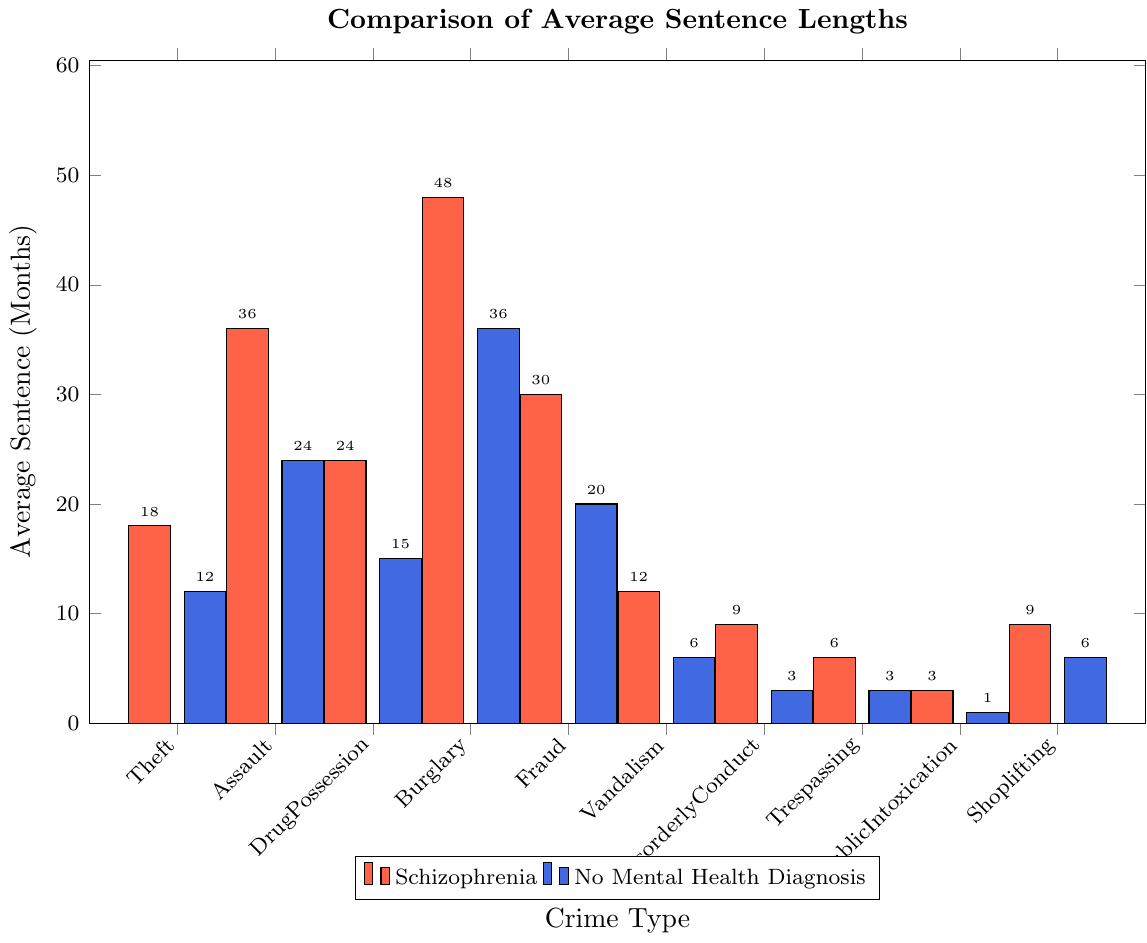Which crime type has the biggest difference in average sentence length between individuals with schizophrenia and those without mental health diagnoses? The difference can be found by subtracting the average sentences of those without mental health diagnoses from those with schizophrenia for each crime, and identifying the largest result. For Burglary, the difference is 48 - 36 = 12 months, this is the largest difference.
Answer: Burglary For which crime type is the average sentence length equal for individuals with schizophrenia and those without mental health diagnoses? By comparing the sentences, it’s clear that for no crime types are the sentences equal.
Answer: None What is the total average sentence length for all crime types for individuals with schizophrenia? Adding the average sentences for all crimes for individuals with schizophrenia: 18 + 36 + 24 + 48 + 30 + 12 + 9 + 6 + 3 + 9 = 195 months.
Answer: 195 months What is the ratio of the average sentence for Disorderly Conduct between individuals with schizophrenia and those without mental health diagnoses? The average sentence for Disorderly Conduct is 9 months for individuals with schizophrenia and 3 months for those without mental health diagnoses. The ratio is 9/3.
Answer: 3:1 Which crime type has the smallest average sentence length for individuals with schizophrenia? By examining the chart, Public Intoxication has the smallest average sentence length at 3 months for individuals with schizophrenia.
Answer: Public Intoxication Which crime types have an average sentence greater than 20 months for individuals with schizophrenia? By inspecting the chart, the crime types are Assault (36 months), Drug Possession (24 months), Burglary (48 months), and Fraud (30 months).
Answer: Assault, Drug Possession, Burglary, Fraud What is the difference in the average sentence for Fraud between individuals with schizophrenia and those without mental health diagnoses? The average sentences for Fraud are 30 months for individuals with schizophrenia and 20 months for those without. The difference is 30 - 20.
Answer: 10 months Which group has a harsher average sentence for Vandalism? Comparing the average sentences for Vandalism, individuals with schizophrenia have 12 months, while those without mental health diagnoses have 6 months. The group with the harsher sentence is individuals with schizophrenia.
Answer: Individuals with schizophrenia For Theft, the average sentence for individuals with schizophrenia is how many months longer than for those without mental health diagnoses? The average sentence for Theft is 18 months for individuals with schizophrenia and 12 months for those without. The difference is 18 - 12.
Answer: 6 months What is the combined average sentence for Trespassing and Shoplifting for individuals with schizophrenia? Adding the average sentences for Trespassing and Shoplifting: 6 + 9 = 15 months.
Answer: 15 months 